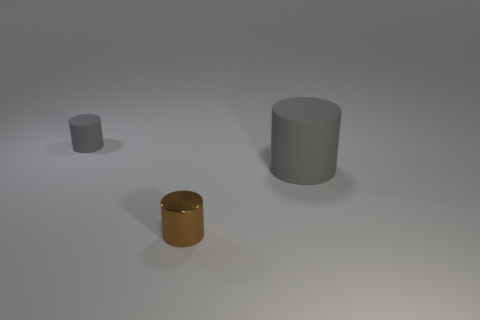There is a large gray rubber thing that is right of the shiny object; what shape is it?
Provide a succinct answer. Cylinder. What is the color of the tiny cylinder that is right of the tiny cylinder left of the metallic thing?
Provide a succinct answer. Brown. The big matte object that is the same shape as the metallic thing is what color?
Offer a very short reply. Gray. How many shiny cylinders have the same color as the metallic thing?
Your response must be concise. 0. There is a small metallic cylinder; does it have the same color as the cylinder on the left side of the small brown metallic cylinder?
Provide a succinct answer. No. The thing that is behind the small metallic cylinder and to the left of the big gray rubber object has what shape?
Give a very brief answer. Cylinder. The tiny thing that is to the right of the tiny object that is on the left side of the tiny cylinder in front of the tiny gray rubber cylinder is made of what material?
Provide a short and direct response. Metal. Is the number of tiny objects that are on the left side of the small brown cylinder greater than the number of large gray cylinders behind the tiny matte cylinder?
Provide a succinct answer. Yes. How many other big cylinders are made of the same material as the large gray cylinder?
Make the answer very short. 0. Do the rubber thing that is left of the brown thing and the gray rubber thing to the right of the metallic thing have the same shape?
Provide a short and direct response. Yes. 